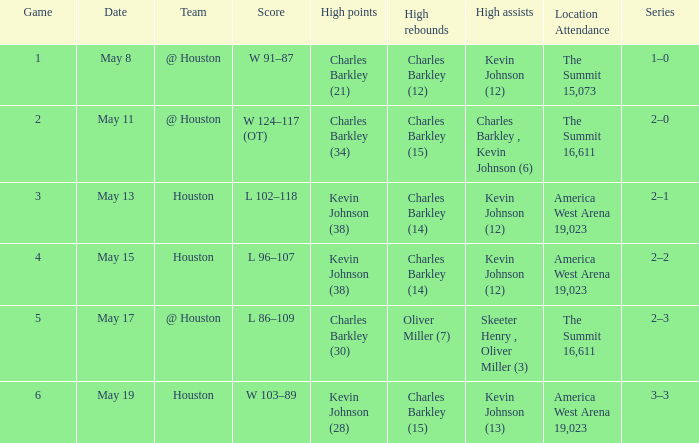Who achieved the most assists in the match where charles barkley (21) scored the highest points? Kevin Johnson (12). 